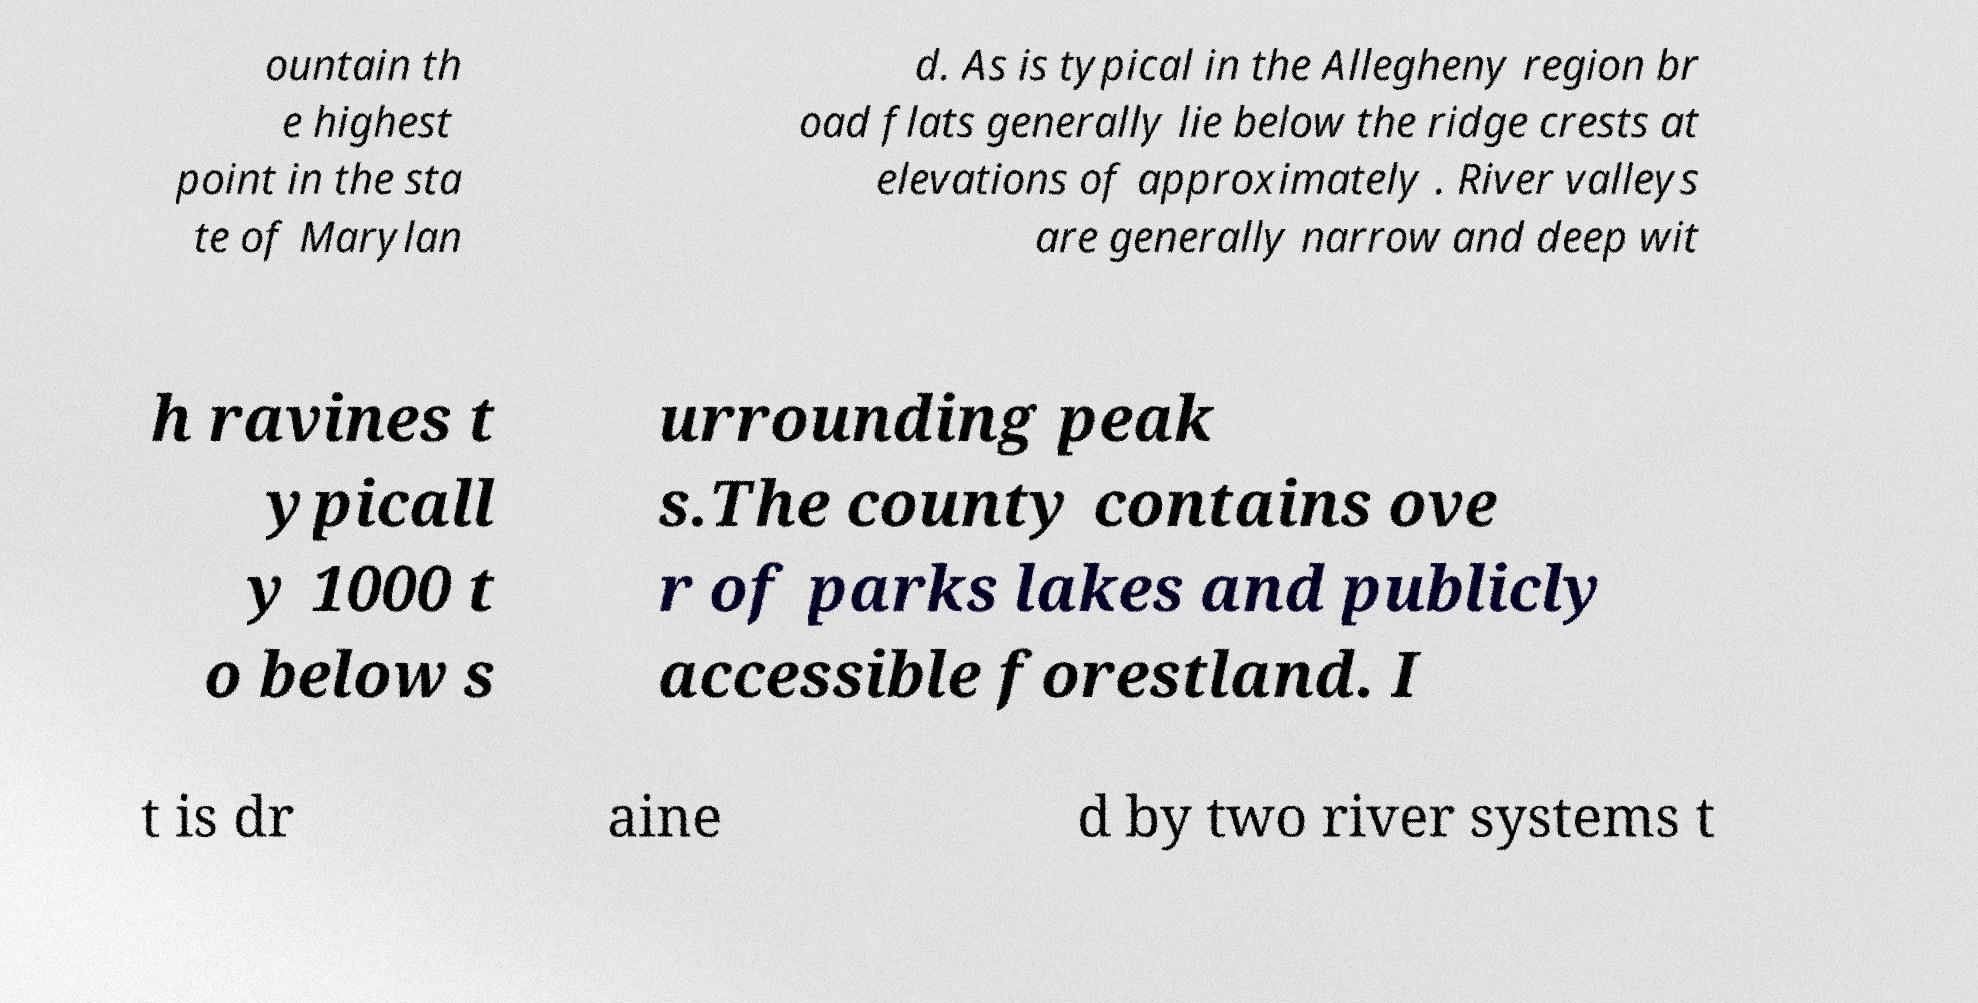Could you extract and type out the text from this image? ountain th e highest point in the sta te of Marylan d. As is typical in the Allegheny region br oad flats generally lie below the ridge crests at elevations of approximately . River valleys are generally narrow and deep wit h ravines t ypicall y 1000 t o below s urrounding peak s.The county contains ove r of parks lakes and publicly accessible forestland. I t is dr aine d by two river systems t 